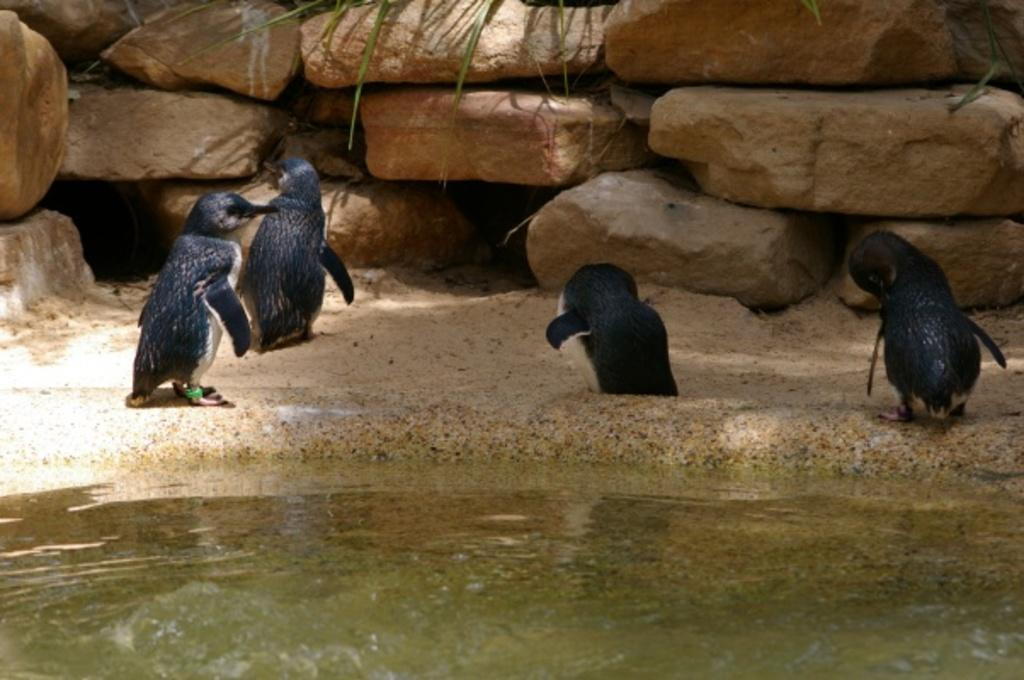How many baby penguins are in the image? There are four baby penguins in the image. Where are the penguins located in relation to the water? The penguins are beside the water. What is in front of the penguins? There are huge rocks in front of the penguins. What type of discussion is taking place between the penguins and the pear in the image? There is no discussion or pear present in the image; it features four baby penguins beside the water with huge rocks in front of them. 